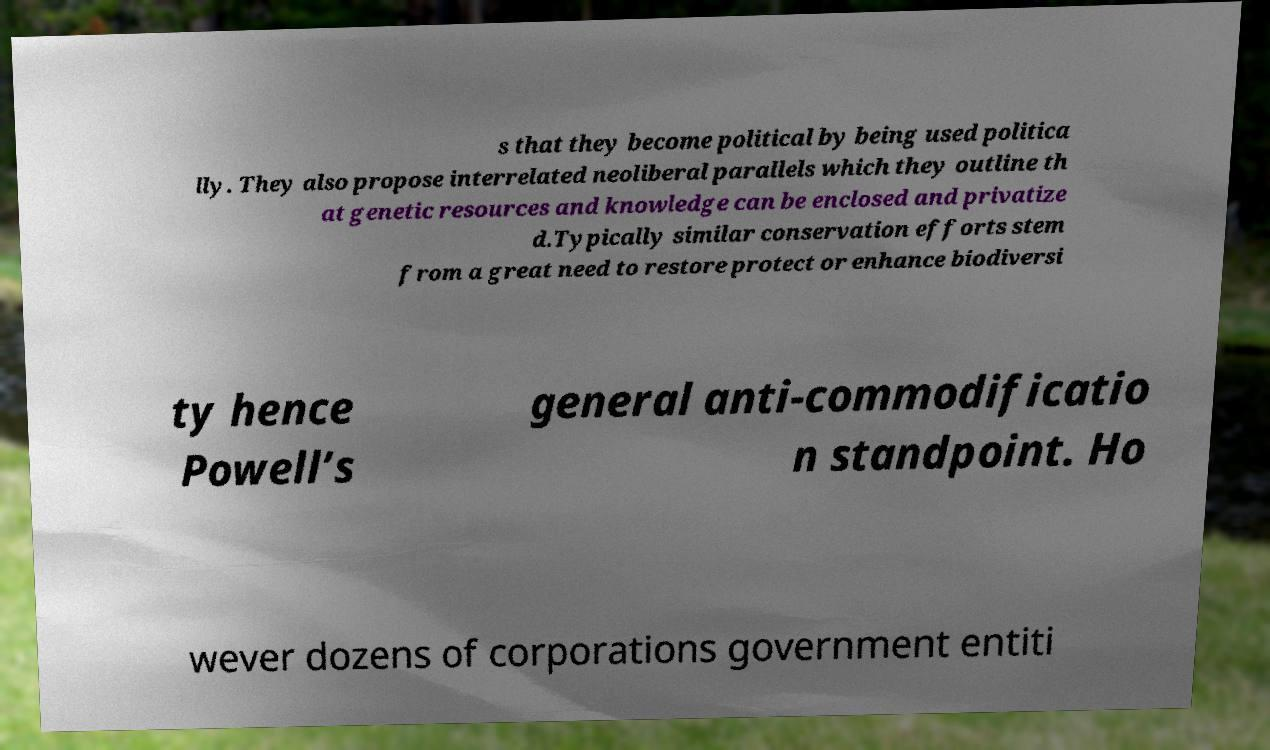Could you extract and type out the text from this image? s that they become political by being used politica lly. They also propose interrelated neoliberal parallels which they outline th at genetic resources and knowledge can be enclosed and privatize d.Typically similar conservation efforts stem from a great need to restore protect or enhance biodiversi ty hence Powell’s general anti-commodificatio n standpoint. Ho wever dozens of corporations government entiti 